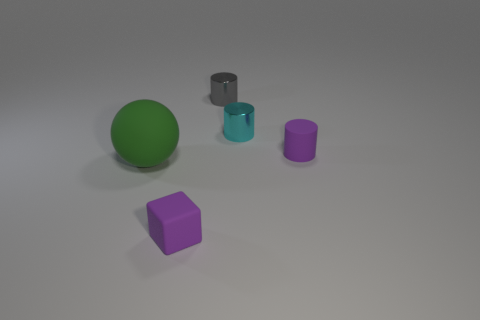What number of cubes are either small purple objects or large gray matte objects?
Offer a terse response. 1. There is a purple thing that is the same shape as the cyan metallic thing; what material is it?
Your answer should be compact. Rubber. What is the size of the purple object that is made of the same material as the purple cube?
Your answer should be compact. Small. Do the small purple matte thing that is behind the big green sphere and the small metallic object to the right of the gray cylinder have the same shape?
Keep it short and to the point. Yes. The cylinder that is made of the same material as the gray thing is what color?
Your answer should be very brief. Cyan. Does the cyan cylinder behind the big green rubber ball have the same size as the object to the left of the cube?
Your answer should be compact. No. What is the shape of the object that is both in front of the tiny matte cylinder and on the right side of the big ball?
Provide a succinct answer. Cube. Are there any big things made of the same material as the block?
Keep it short and to the point. Yes. There is a tiny cylinder that is the same color as the cube; what is its material?
Your answer should be very brief. Rubber. Are the small purple object that is behind the big green object and the cyan cylinder that is behind the large rubber object made of the same material?
Your answer should be compact. No. 